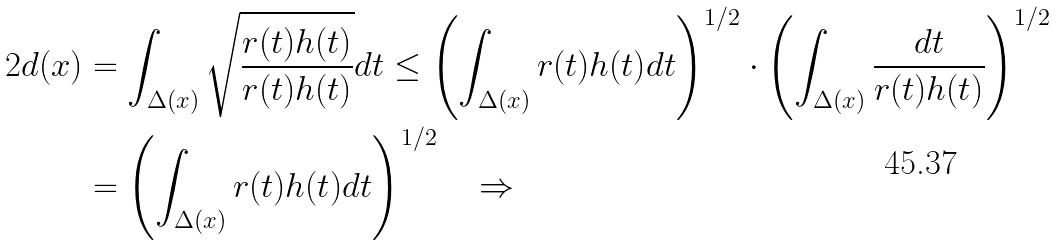<formula> <loc_0><loc_0><loc_500><loc_500>2 d ( x ) & = \int _ { \Delta ( x ) } \sqrt { \frac { r ( t ) h ( t ) } { r ( t ) h ( t ) } } d t \leq \left ( \int _ { \Delta ( x ) } r ( t ) h ( t ) d t \right ) ^ { 1 / 2 } \cdot \left ( \int _ { \Delta ( x ) } \frac { d t } { r ( t ) h ( t ) } \right ) ^ { 1 / 2 } \\ & = \left ( \int _ { \Delta ( x ) } r ( t ) h ( t ) d t \right ) ^ { 1 / 2 } \quad \Rightarrow</formula> 